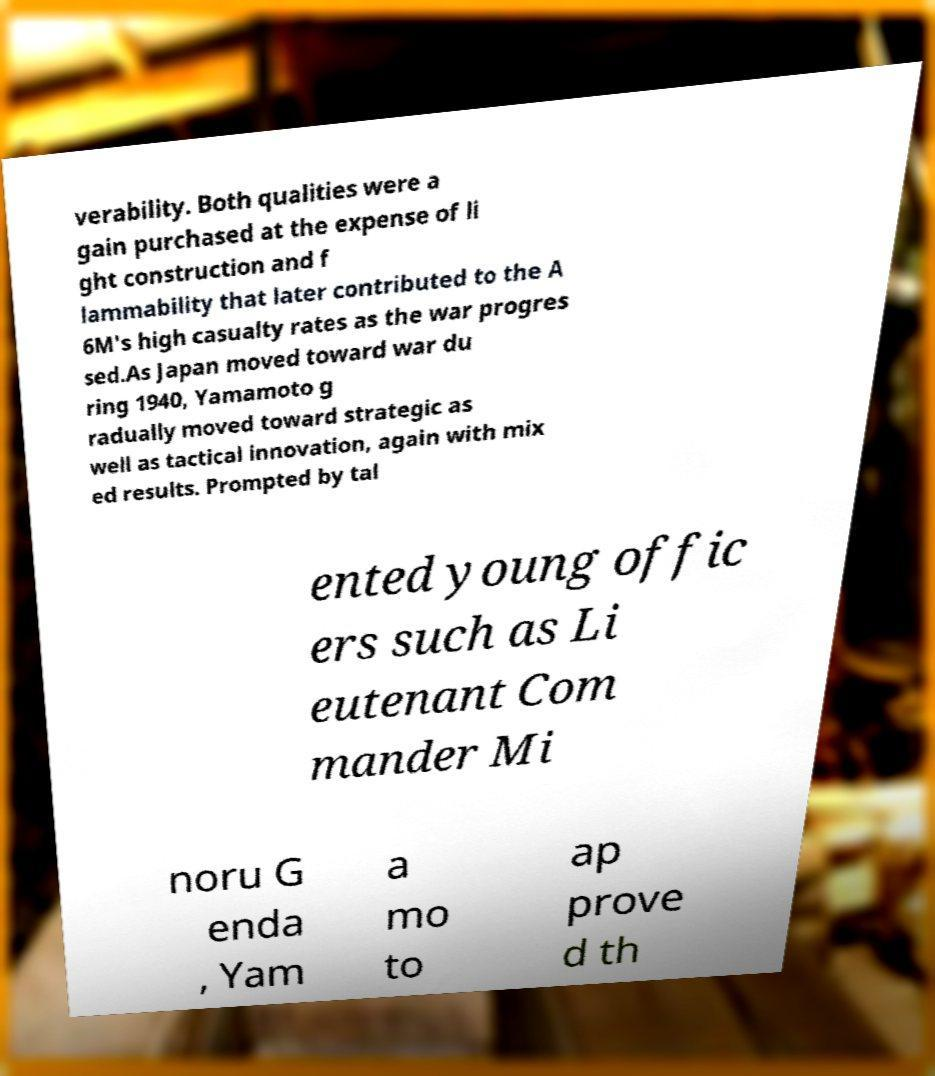What messages or text are displayed in this image? I need them in a readable, typed format. verability. Both qualities were a gain purchased at the expense of li ght construction and f lammability that later contributed to the A 6M's high casualty rates as the war progres sed.As Japan moved toward war du ring 1940, Yamamoto g radually moved toward strategic as well as tactical innovation, again with mix ed results. Prompted by tal ented young offic ers such as Li eutenant Com mander Mi noru G enda , Yam a mo to ap prove d th 